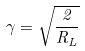<formula> <loc_0><loc_0><loc_500><loc_500>\gamma = \sqrt { \frac { 2 } { R _ { L } } }</formula> 